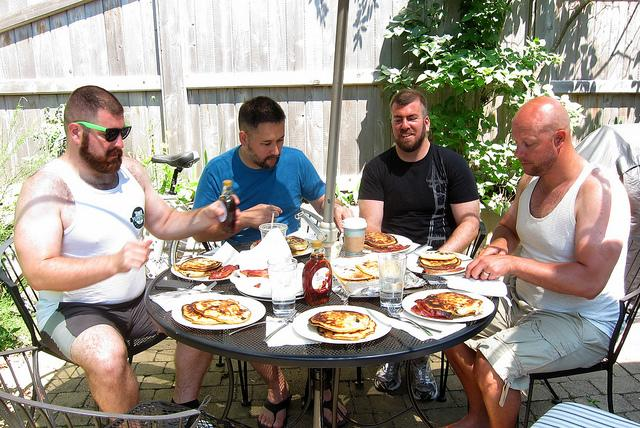What food on the table has the highest level of fat? Please explain your reasoning. bacon. The food is bacon. 